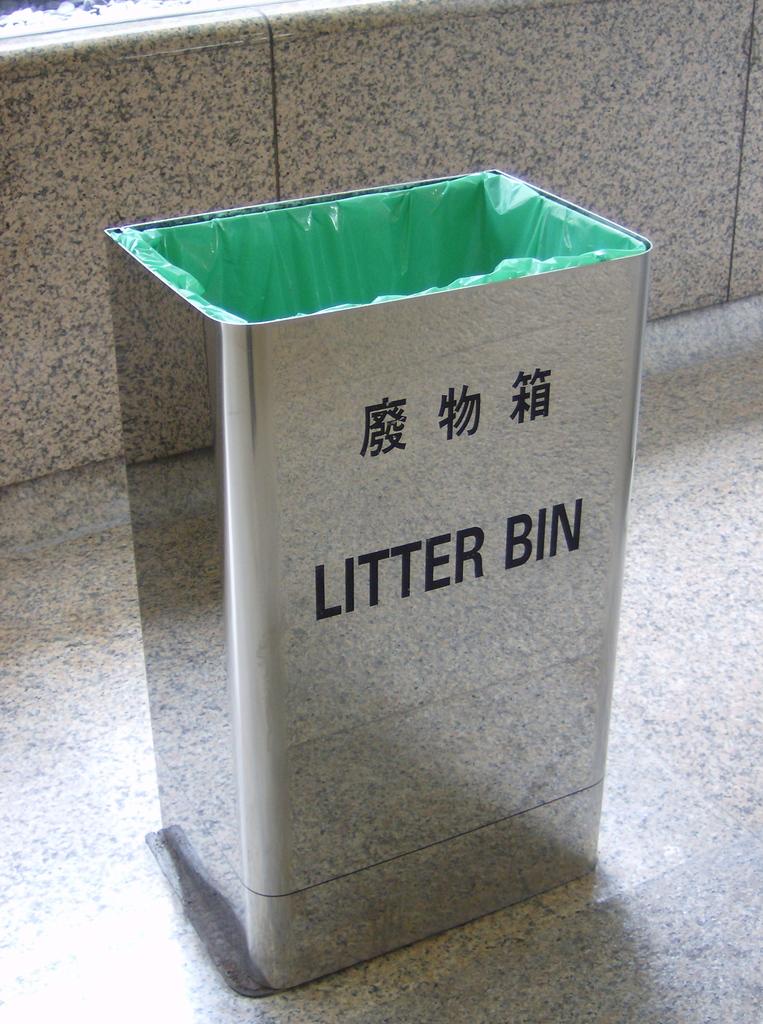What kind of bin is this?
Offer a terse response. Litter. 